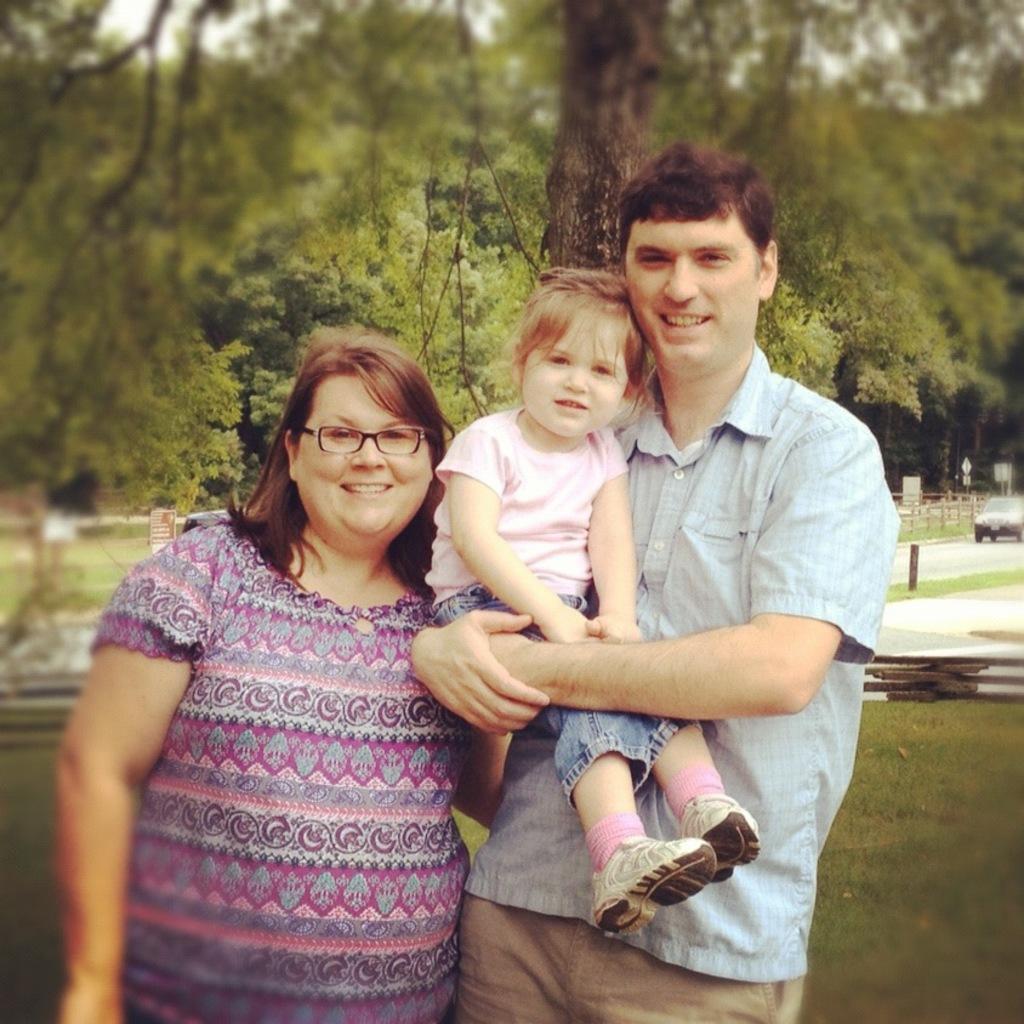In one or two sentences, can you explain what this image depicts? In this picture, we see the woman and the men are standing. He is holding the girl in his hands. They are smiling and they are posing for the photo. At the bottom, we see the grass. On the right side, we see the car is moving on the road. Beside that, we see the wooden fence. We see the wooden sticks. There are trees in the background. 